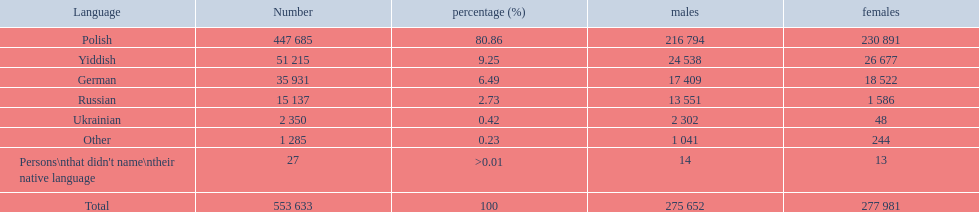What was the highest percentage of one language spoken by the plock governorate? 80.86. What language was spoken by 80.86 percent of the people? Polish. 